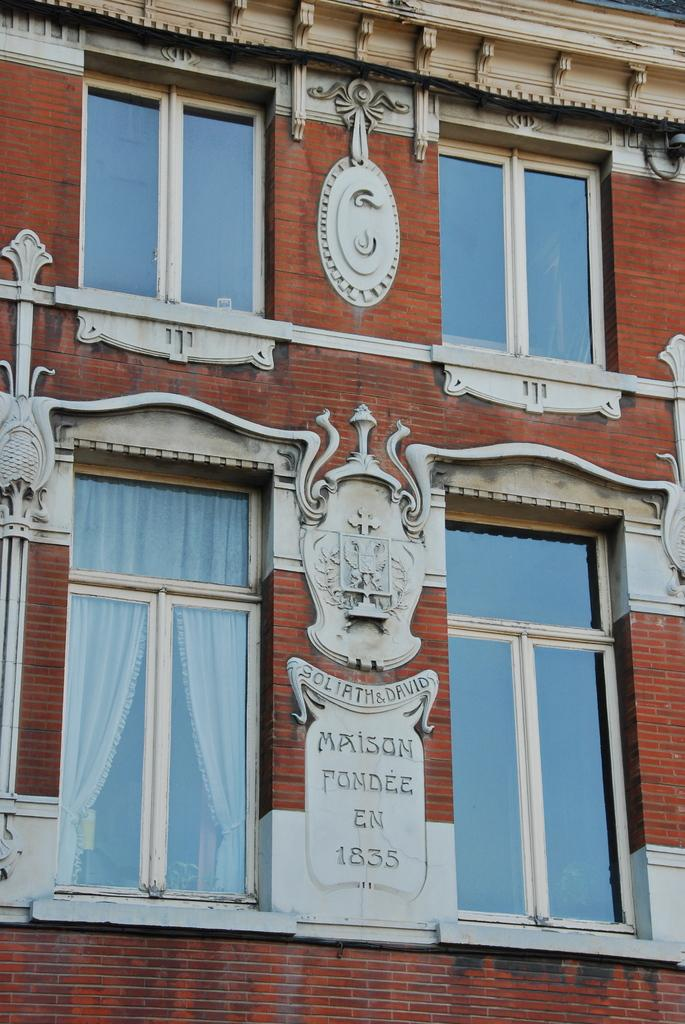What is the main subject of the image? The main subject of the image is a building. Can you describe any specific features of the building? Yes, there are four windows in the middle of the image. What type of jam is being spread on the tub in the image? There is no tub or jam present in the image; it is a zoomed-in picture of a building with four windows. 